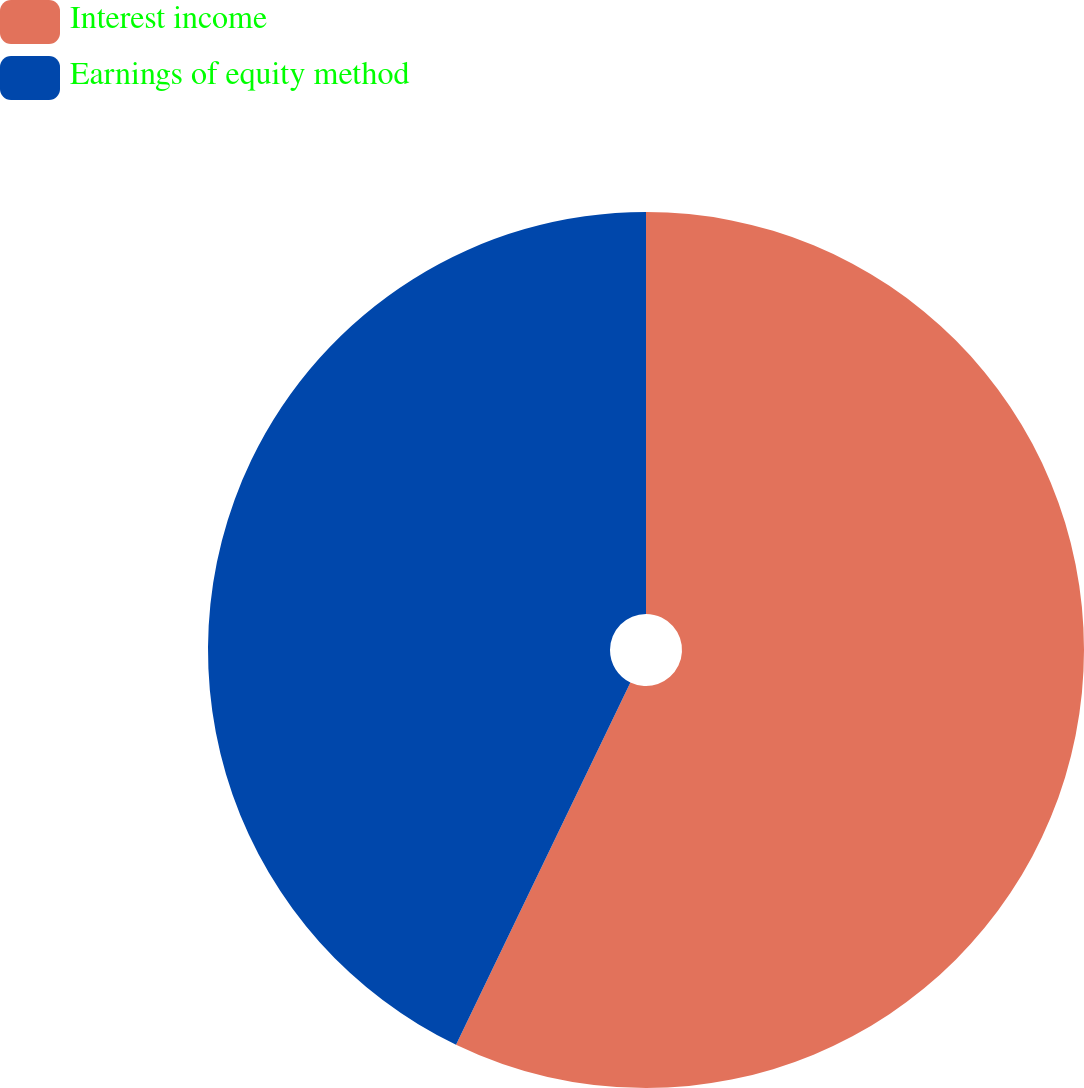<chart> <loc_0><loc_0><loc_500><loc_500><pie_chart><fcel>Interest income<fcel>Earnings of equity method<nl><fcel>57.14%<fcel>42.86%<nl></chart> 